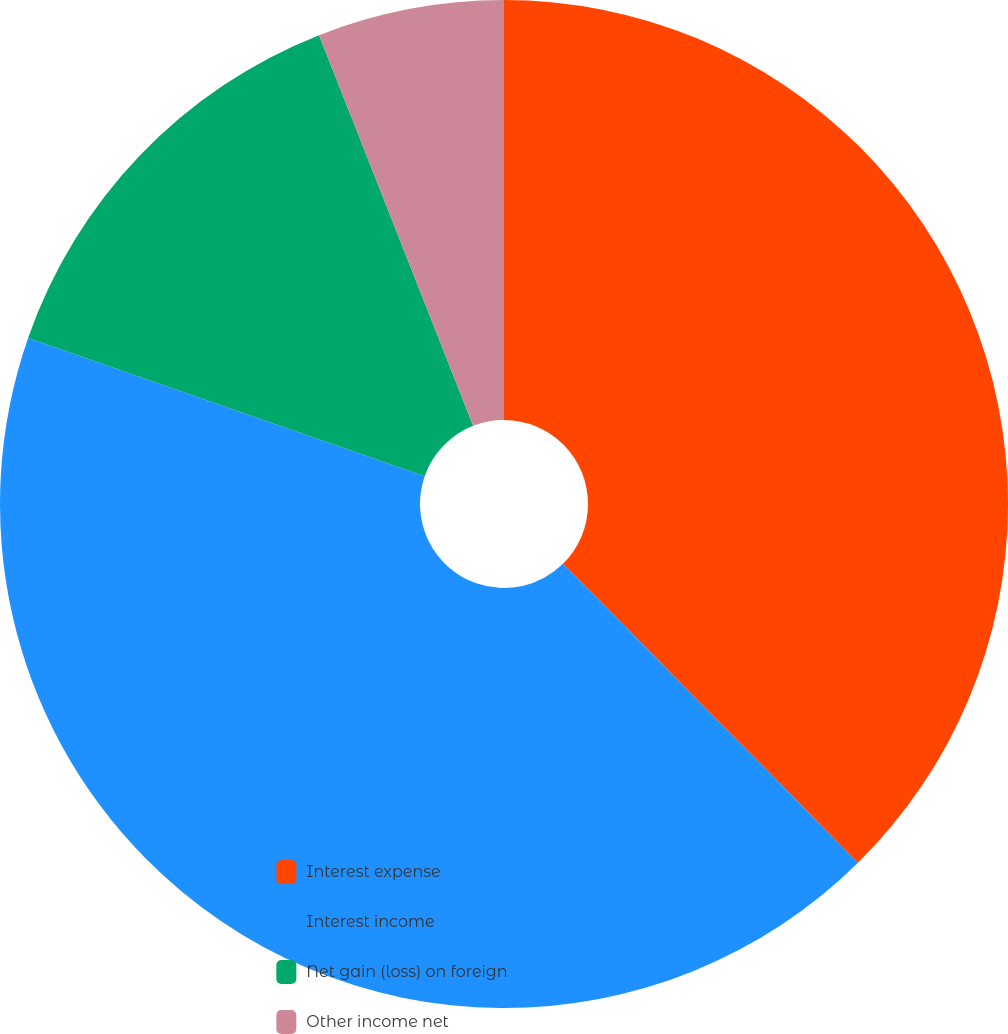Convert chart. <chart><loc_0><loc_0><loc_500><loc_500><pie_chart><fcel>Interest expense<fcel>Interest income<fcel>Net gain (loss) on foreign<fcel>Other income net<nl><fcel>37.61%<fcel>42.74%<fcel>13.68%<fcel>5.98%<nl></chart> 